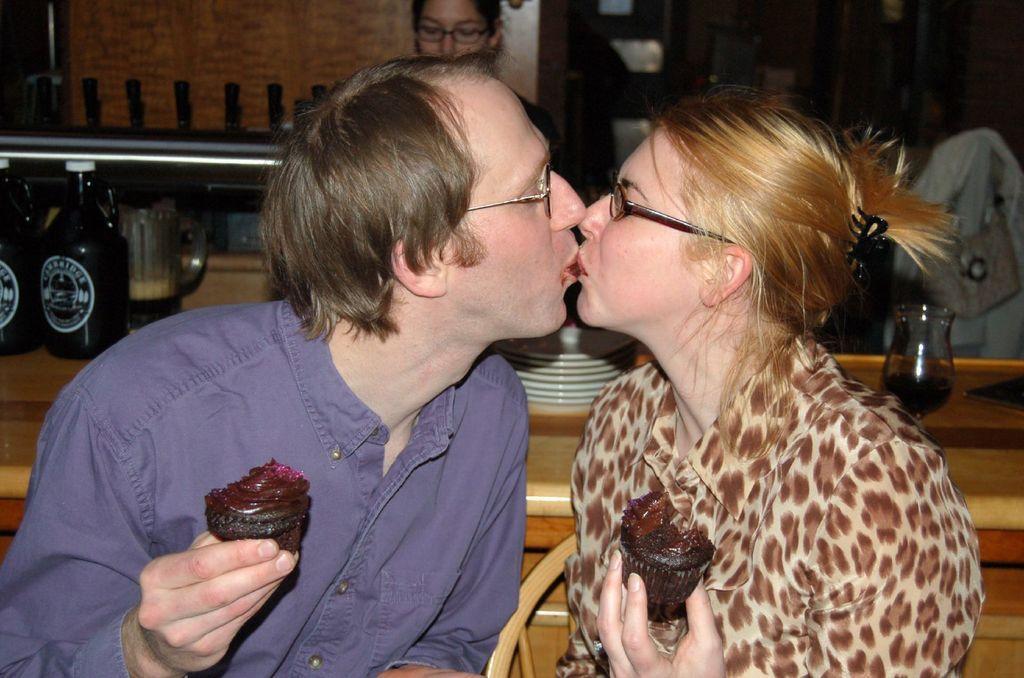Could you give a brief overview of what you see in this image? In this picture there are a man and a woman holding cupcakes and kissing, behind them there are plates, glass, bottles and a woman. In the background there is a glass window and wall. 